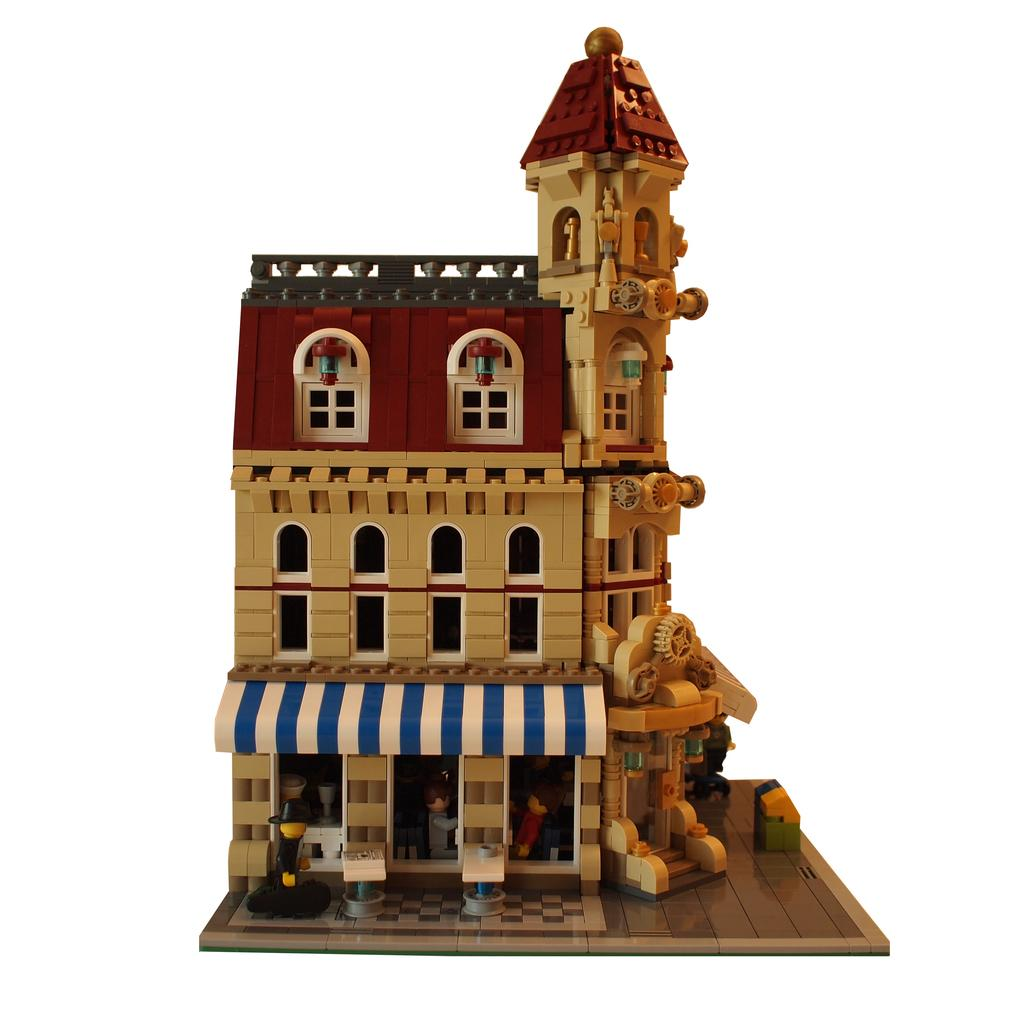What type of structure is visible in the image? There is a building in the image. What material is the building made of? The building is made up of plastic blocks. What color is the building? The building is in brown color. Is the moon visible in the image? No, the moon is not visible in the image. What type of quiver is used to store the plastic blocks in the image? There is no quiver present in the image, as the plastic blocks are already assembled into a building. 